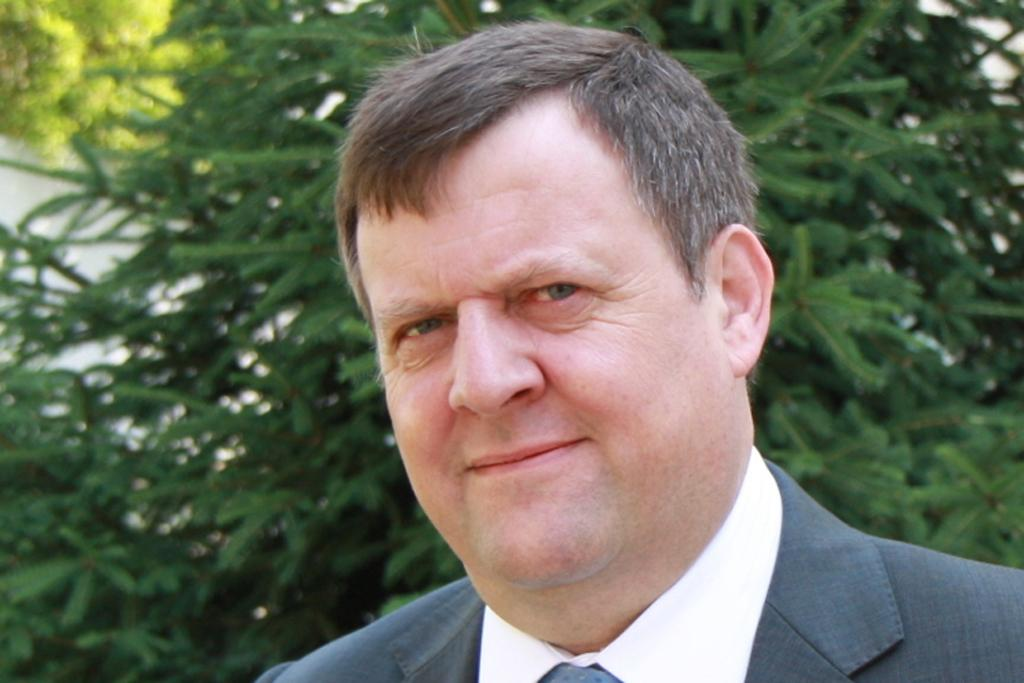What is the main subject of the image? There is a person's face in the image. What direction is the person looking in the image? The person is looking forward. How would you describe the background of the image? The background of the image is blurred. What type of natural environment can be seen in the image? Trees are visible in the background of the image. What type of bag is hanging from the person's shoulder in the image? There is no bag visible in the image; it only shows a person's face. What type of cord is connected to the person's ear in the image? There is no cord or any indication of headphones or earbuds in the image. 